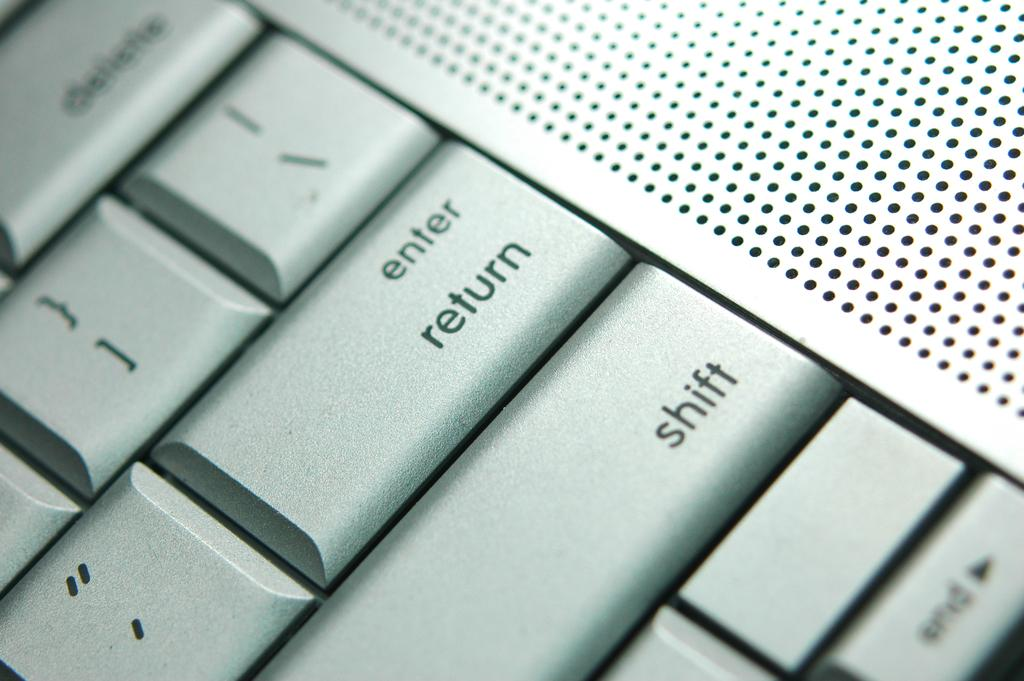Provide a one-sentence caption for the provided image. a closeup of a computer keyboard with enter/return and shift keys shown. 